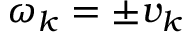Convert formula to latex. <formula><loc_0><loc_0><loc_500><loc_500>\omega _ { k } = \pm v _ { k }</formula> 